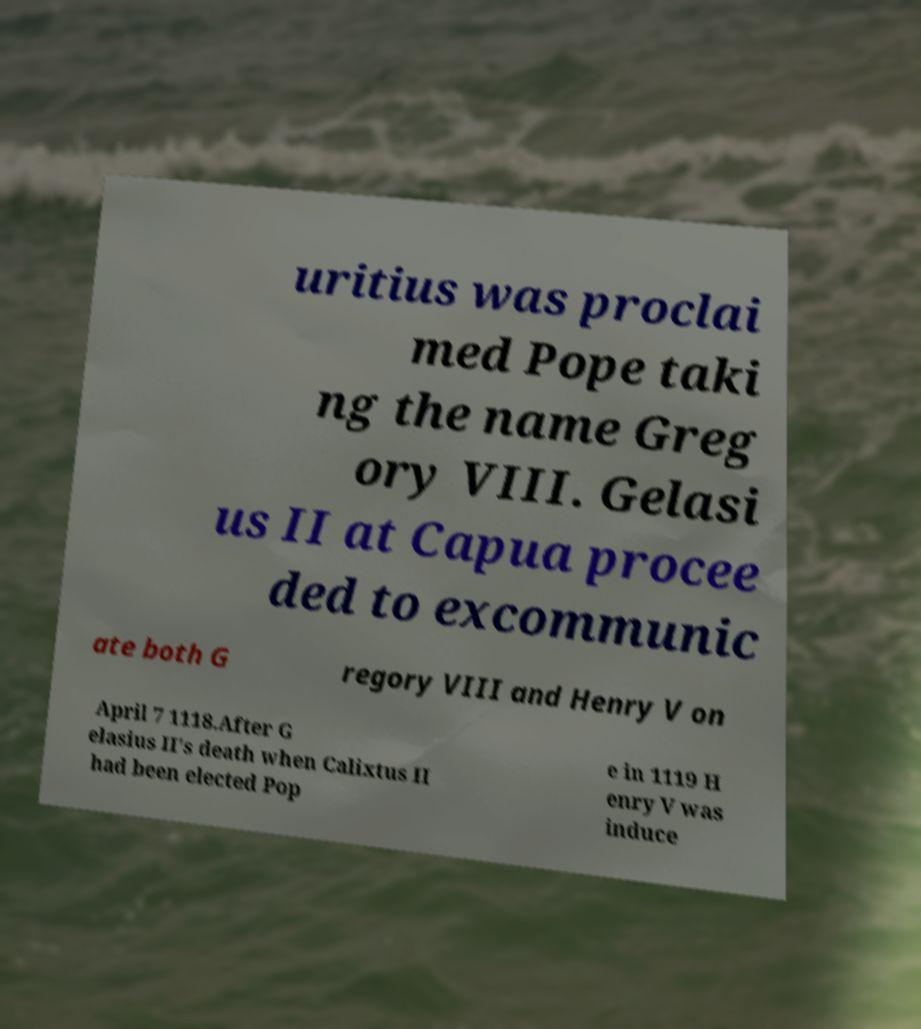I need the written content from this picture converted into text. Can you do that? uritius was proclai med Pope taki ng the name Greg ory VIII. Gelasi us II at Capua procee ded to excommunic ate both G regory VIII and Henry V on April 7 1118.After G elasius II's death when Calixtus II had been elected Pop e in 1119 H enry V was induce 